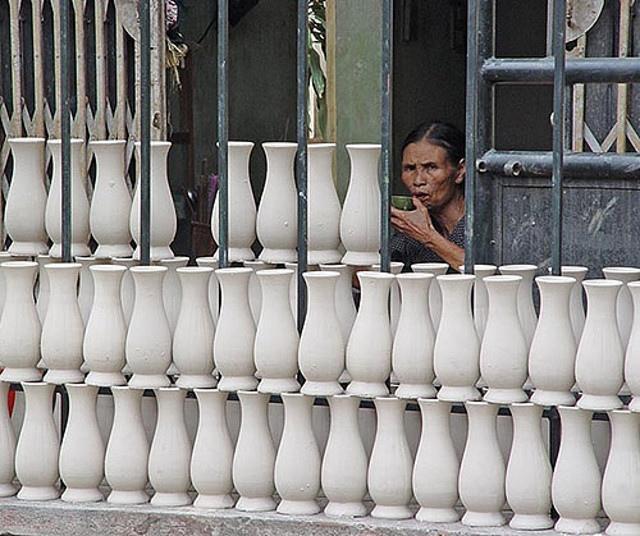How many vases are in the picture?
Give a very brief answer. 14. 